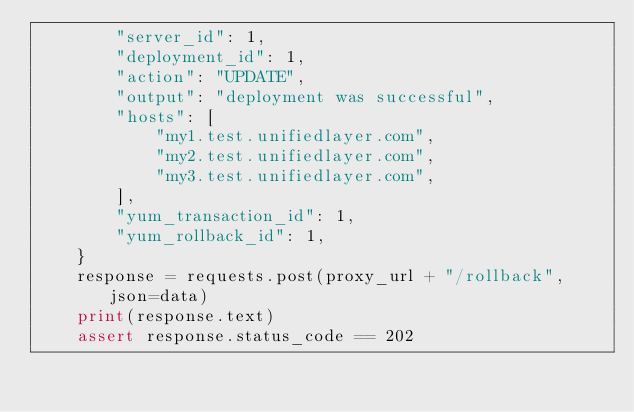Convert code to text. <code><loc_0><loc_0><loc_500><loc_500><_Python_>        "server_id": 1,
        "deployment_id": 1,
        "action": "UPDATE",
        "output": "deployment was successful",
        "hosts": [
            "my1.test.unifiedlayer.com",
            "my2.test.unifiedlayer.com",
            "my3.test.unifiedlayer.com",
        ],
        "yum_transaction_id": 1,
        "yum_rollback_id": 1,
    }
    response = requests.post(proxy_url + "/rollback", json=data)
    print(response.text)
    assert response.status_code == 202
</code> 